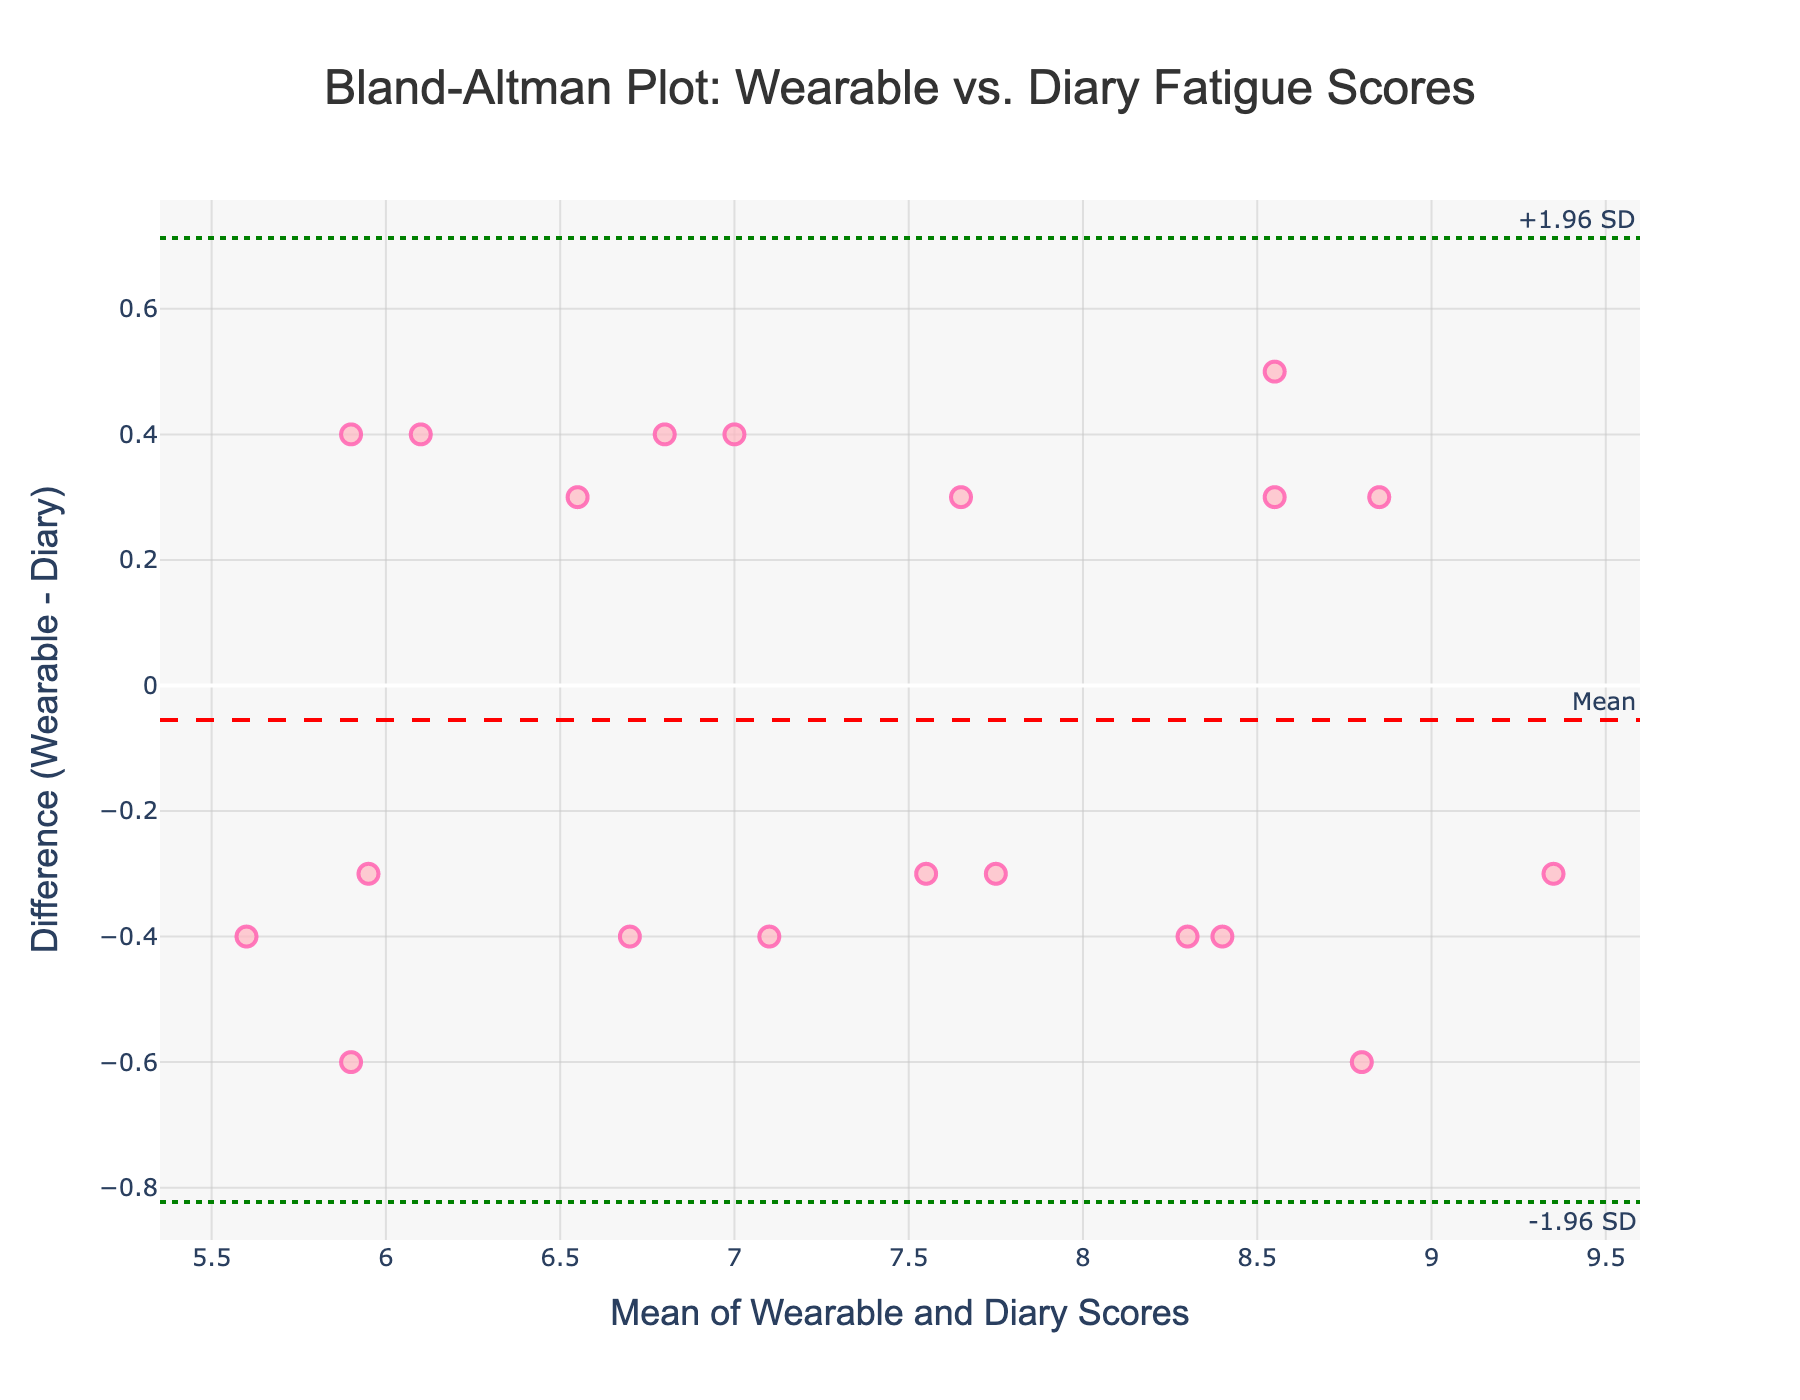What is the title of the plot? The title of the plot is usually displayed at the top. In this case, it is 'Bland-Altman Plot: Wearable vs. Diary Fatigue Scores'.
Answer: 'Bland-Altman Plot: Wearable vs. Diary Fatigue Scores' What do the x-axis and y-axis represent in the plot? The x-axis title is 'Mean of Wearable and Diary Scores', and the y-axis title is 'Difference (Wearable - Diary)'. This indicates the x-axis shows the average fatigue scores from both wearable devices and diary entries, while the y-axis shows the difference between these two scores.
Answer: The x-axis shows the mean of wearable and diary scores, and the y-axis shows the difference (Wearable - Diary) How many data points are plotted on this graph? Each participant's data forms a single point on the plot. By counting the participants listed in the table, we find there are 20 participants. Hence, there should be 20 points on the graph.
Answer: 20 What is the mean difference between the wearable and diary fatigue scores? The mean difference is visually represented by a dashed red line, labeled 'Mean'. This line is placed at the value typical of the mean difference between the wearable and diary scores.
Answer: Mean difference is shown as a dashed red line What do the green dotted lines represent on the plot? The green dotted lines labeled +1.96 SD and -1.96 SD stand for the limits of agreement. They represent the range that contains most of the differences, typically 95% of them.
Answer: Limits of agreement Is the mean difference positive or negative? Observing the y-position of the dashed red line labeled 'Mean' relative to the y=0 line, we find it is slightly above zero, indicating a positive mean difference.
Answer: Positive Which participant has the highest average fatigue score? To identify the participant with the highest average fatigue score, look at the data points along the x-axis and locate the one farthest to the right. This corresponds to the 'Mean of Wearable and Diary Scores'. From the data, Liam Brown has the highest individual scores, likely placing his average fatigue score the highest.
Answer: Liam Brown What is the value of the upper limit of agreement? The upper limit of agreement is indicated by the green dotted line labeled '+1.96 SD'. The precise value can be visually estimated from the y-axis.
Answer: Upper limit is '+1.96 SD' How wide is the range between the limits of agreement? Calculate the range by subtracting the lower limit from the upper limit. The upper limit is 'Mean + 1.96 SD' and the lower limit is 'Mean - 1.96 SD'. Simplifying, we get the range to be ‘1.96 SD * 2’ which equals approximately ‘3.92 SD’.
Answer: Approximately 3.92 SD 